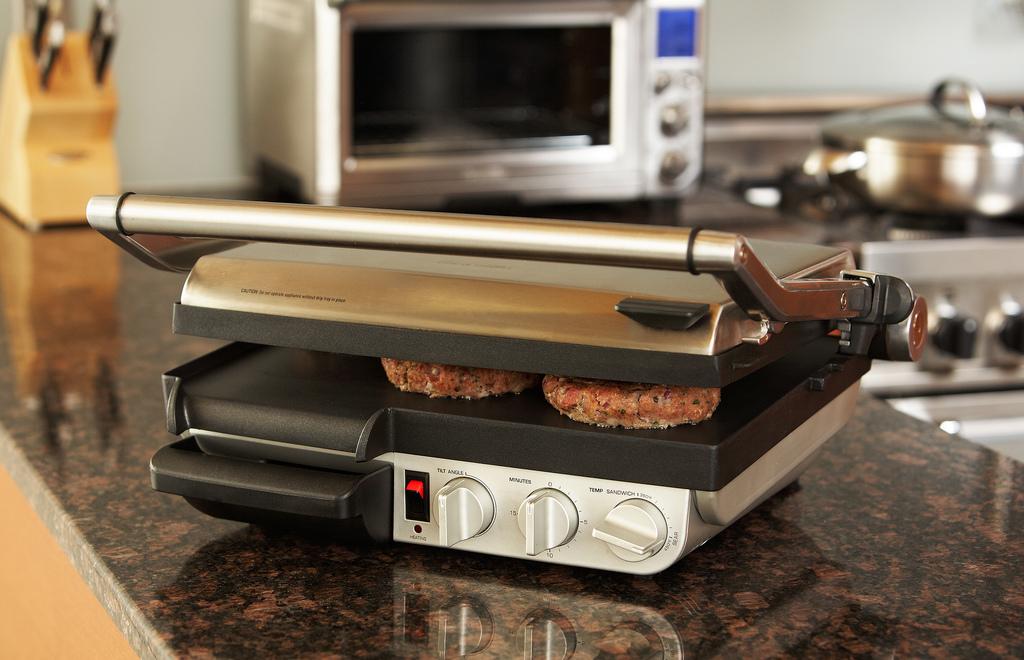What is the name for the dial on the left?
Provide a short and direct response. Tilt angle. What is measured with the dial in the middle?
Keep it short and to the point. Minutes. 